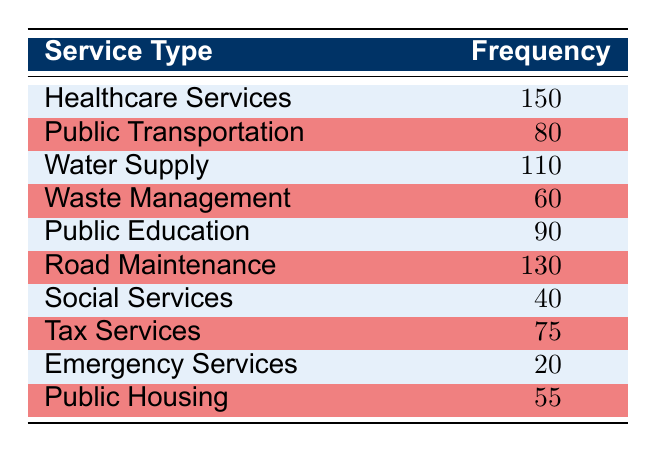What is the type of service with the highest number of complaints? The table shows the frequency of complaints per service type. By comparing the frequencies, Healthcare Services has the highest frequency with 150 complaints.
Answer: Healthcare Services What is the frequency of complaints regarding Public Transportation? The table lists Public Transportation with a frequency of 80 complaints.
Answer: 80 How many complaints were recorded for Water Supply compared to Waste Management? Water Supply has 110 complaints, while Waste Management has 60 complaints. The difference is 110 - 60 = 50.
Answer: 50 What is the total number of complaints for Public Education and Road Maintenance combined? Public Education has 90 complaints and Road Maintenance has 130 complaints. Summing these gives 90 + 130 = 220.
Answer: 220 Is it true that Emergency Services has more complaints than Social Services? Emergency Services has 20 complaints while Social Services has 40 complaints. Thus, the statement is false as 20 is less than 40.
Answer: No What is the average number of complaints across all service types? To find the average, we sum all the frequencies: 150 + 80 + 110 + 60 + 90 + 130 + 40 + 75 + 20 + 55 = 810. There are 10 service types, so the average is 810 / 10 = 81.
Answer: 81 Which service type has the lowest frequency of complaints? The service type with the lowest frequency listed in the table is Emergency Services, which has 20 complaints.
Answer: Emergency Services How many service types have more than 100 complaints? Checking the table, the service types with more than 100 complaints are Healthcare Services (150), Water Supply (110), and Road Maintenance (130). Therefore, 3 types have more than 100 complaints.
Answer: 3 